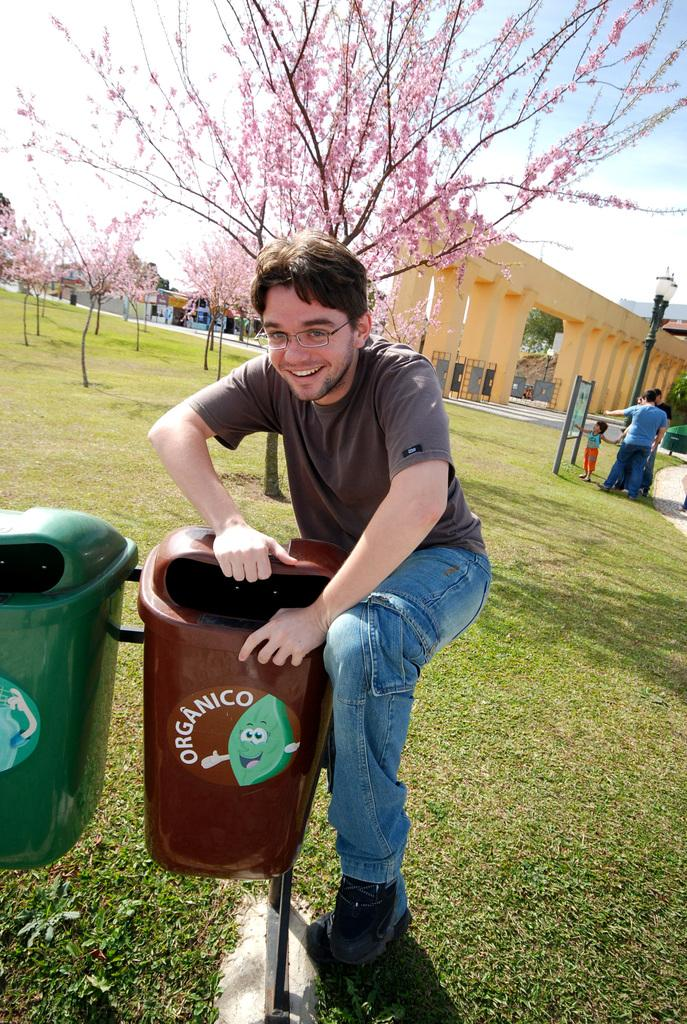<image>
Present a compact description of the photo's key features. a man standing next to a brown Organico recycling box in a park 